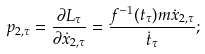Convert formula to latex. <formula><loc_0><loc_0><loc_500><loc_500>p _ { 2 , \tau } = \frac { \partial L _ { \tau } } { \partial \dot { x } _ { 2 , \tau } } = \frac { f ^ { - 1 } ( t _ { \tau } ) m \dot { x } _ { 2 , \tau } } { \dot { t } _ { \tau } } ;</formula> 